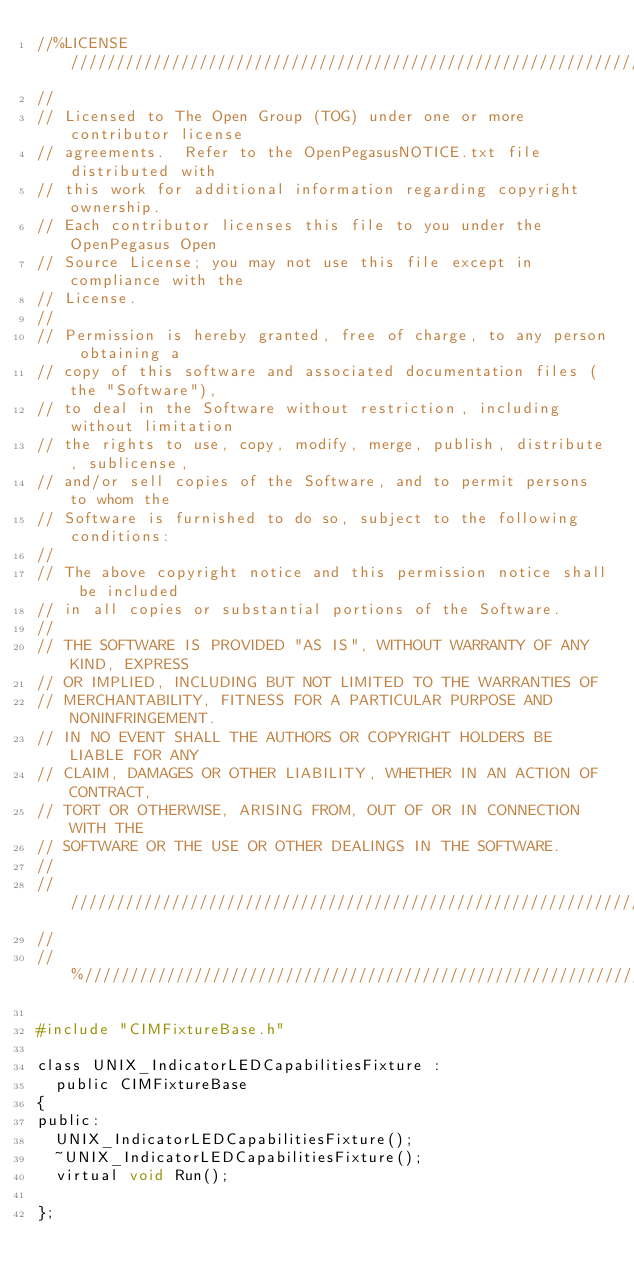Convert code to text. <code><loc_0><loc_0><loc_500><loc_500><_C_>//%LICENSE////////////////////////////////////////////////////////////////
//
// Licensed to The Open Group (TOG) under one or more contributor license
// agreements.  Refer to the OpenPegasusNOTICE.txt file distributed with
// this work for additional information regarding copyright ownership.
// Each contributor licenses this file to you under the OpenPegasus Open
// Source License; you may not use this file except in compliance with the
// License.
//
// Permission is hereby granted, free of charge, to any person obtaining a
// copy of this software and associated documentation files (the "Software"),
// to deal in the Software without restriction, including without limitation
// the rights to use, copy, modify, merge, publish, distribute, sublicense,
// and/or sell copies of the Software, and to permit persons to whom the
// Software is furnished to do so, subject to the following conditions:
//
// The above copyright notice and this permission notice shall be included
// in all copies or substantial portions of the Software.
//
// THE SOFTWARE IS PROVIDED "AS IS", WITHOUT WARRANTY OF ANY KIND, EXPRESS
// OR IMPLIED, INCLUDING BUT NOT LIMITED TO THE WARRANTIES OF
// MERCHANTABILITY, FITNESS FOR A PARTICULAR PURPOSE AND NONINFRINGEMENT.
// IN NO EVENT SHALL THE AUTHORS OR COPYRIGHT HOLDERS BE LIABLE FOR ANY
// CLAIM, DAMAGES OR OTHER LIABILITY, WHETHER IN AN ACTION OF CONTRACT,
// TORT OR OTHERWISE, ARISING FROM, OUT OF OR IN CONNECTION WITH THE
// SOFTWARE OR THE USE OR OTHER DEALINGS IN THE SOFTWARE.
//
//////////////////////////////////////////////////////////////////////////
//
//%/////////////////////////////////////////////////////////////////////////

#include "CIMFixtureBase.h"

class UNIX_IndicatorLEDCapabilitiesFixture :
	public CIMFixtureBase
{
public:
	UNIX_IndicatorLEDCapabilitiesFixture();
	~UNIX_IndicatorLEDCapabilitiesFixture();
	virtual void Run();

};
</code> 